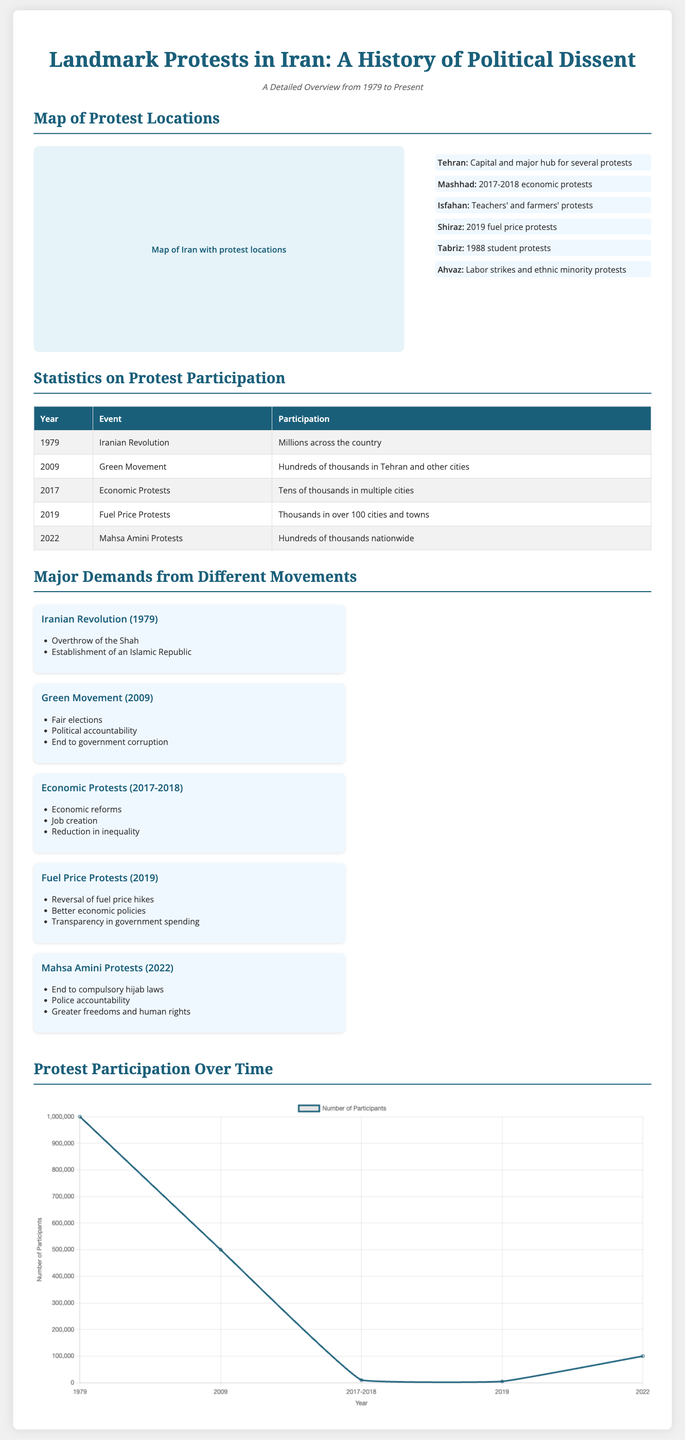What significant event took place in 1979? The document states that the Iranian Revolution occurred in 1979, which was a landmark event.
Answer: Iranian Revolution How many major protests are listed in the statistics table? The table details five significant protests that occurred in different years.
Answer: Five What demand was made during the Mahsa Amini protests? One of the major demands during these protests was to end compulsory hijab laws, as noted in the document.
Answer: End to compulsory hijab laws Which city is noted as the major hub for protests in Iran? The subtitle of the map legend indicates that Tehran is recognized as the capital and major hub for protests.
Answer: Tehran What was the participation level during the Green Movement of 2009? The document states that participation during the Green Movement was hundreds of thousands, as captured in the table.
Answer: Hundreds of thousands Where did the 2017-2018 economic protests primarily occur? The map legend specifically lists Mashhad as a location where significant economic protests took place.
Answer: Mashhad What year saw the highest number of protest participants? Based on the line chart, the Iranian Revolution (1979) had millions participating, making it the highest.
Answer: Millions Which two main demands were made during the Iranian Revolution? The document outlines that the major demands were the overthrow of the Shah and establishment of an Islamic Republic.
Answer: Overthrow of the Shah, Establishment of an Islamic Republic What type of chart is used to visualize protest participation over time? The document uses a line chart to represent the data on protest participation across various years.
Answer: Line chart 